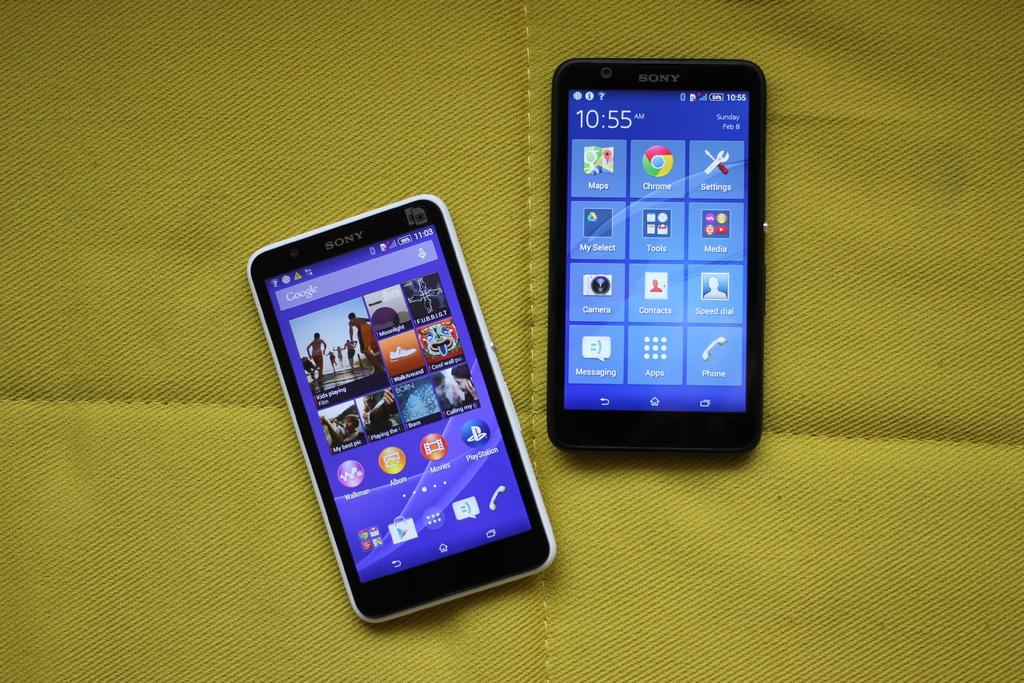What type of furniture is present in the image? There is a table in the image. What electronic devices can be seen on the table? There are two mobile phones on the table. Can you tell me how many balloons are floating on the floor in the image? There are no balloons present in the image. What type of existence can be observed in the image? The image depicts a physical existence of objects, such as the table and mobile phones. 